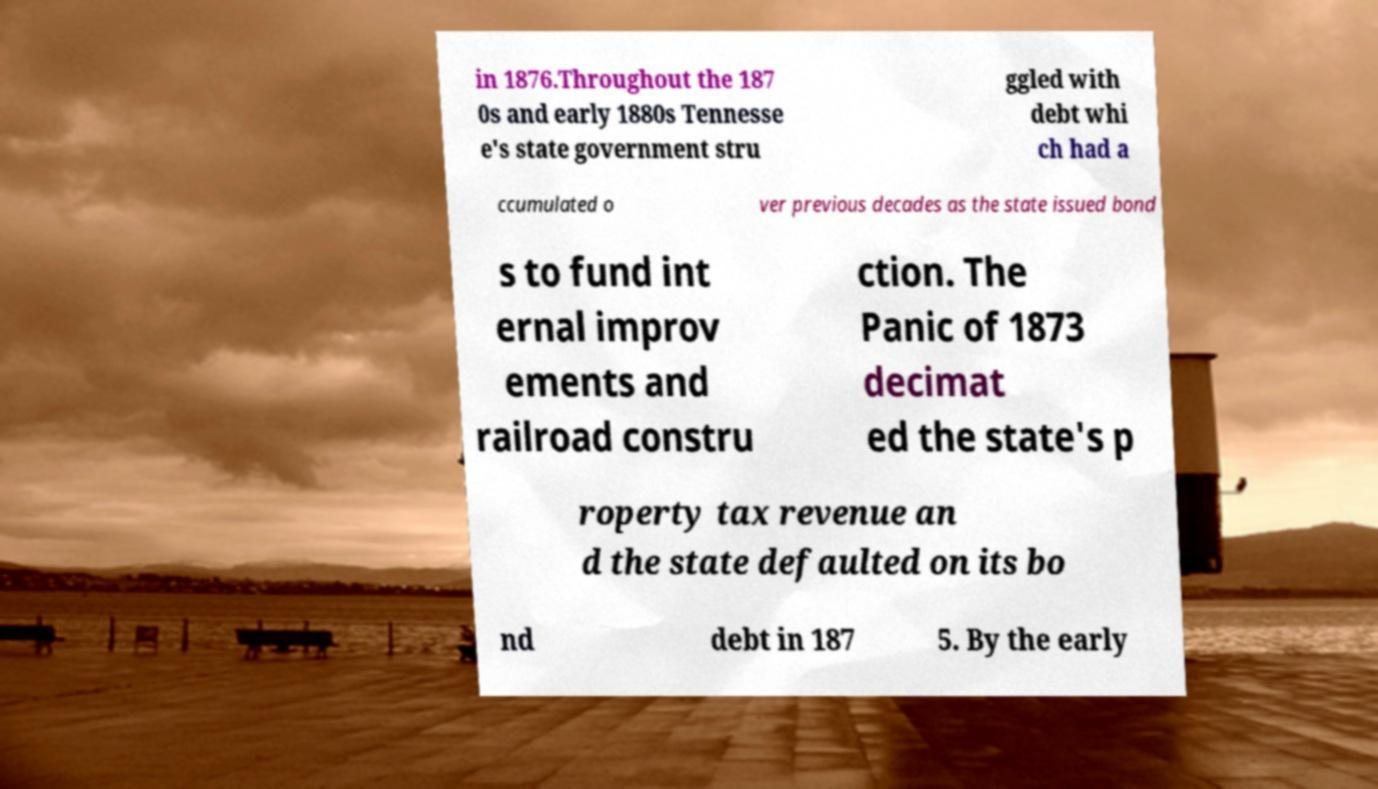Could you assist in decoding the text presented in this image and type it out clearly? in 1876.Throughout the 187 0s and early 1880s Tennesse e's state government stru ggled with debt whi ch had a ccumulated o ver previous decades as the state issued bond s to fund int ernal improv ements and railroad constru ction. The Panic of 1873 decimat ed the state's p roperty tax revenue an d the state defaulted on its bo nd debt in 187 5. By the early 